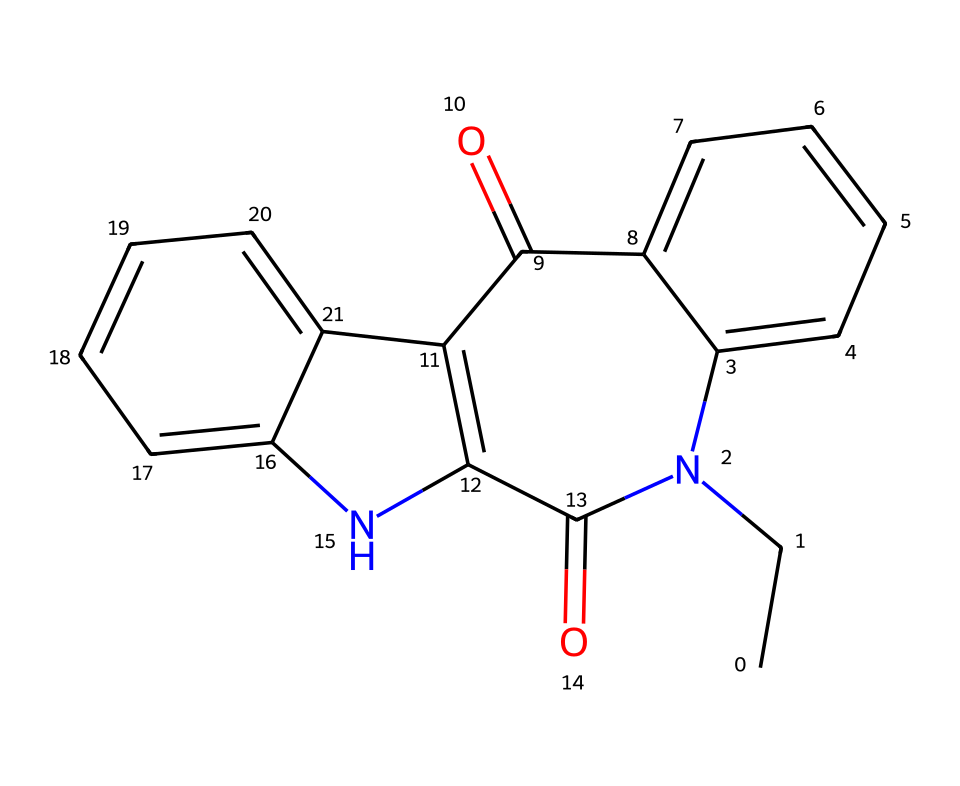How many nitrogen atoms are present in this chemical? By examining the SMILES representation, we can see that there are two instances of the letter 'N', which indicates the presence of two nitrogen atoms in the molecular structure.
Answer: 2 What is the total number of carbon atoms in this molecule? In the provided SMILES representation, we count the number of 'C' characters, which totals to 14 carbon atoms present in the structure.
Answer: 14 Does this chemical contain any double bonds? The presence of '=' in the SMILES notation indicates double bonds; by analyzing the structure, we can identify multiple '=' signs, confirming the existence of double bonds within the molecule.
Answer: yes What type of functional group is indicated by the 'C(=O)' in the SMILES? The 'C(=O)' notation points to a carbonyl group, which is characteristic of ketones or aldehydes, depending on the structure's context; in this case, it indicates a ketone part of the structure.
Answer: ketone Is this compound likely to have psychoactive properties? Given that this molecule is an alkaloid, a class of compounds known for their psychoactive effects, along with the presence of nitrogen, it is reasonable to infer that it may have psychoactive properties.
Answer: yes 